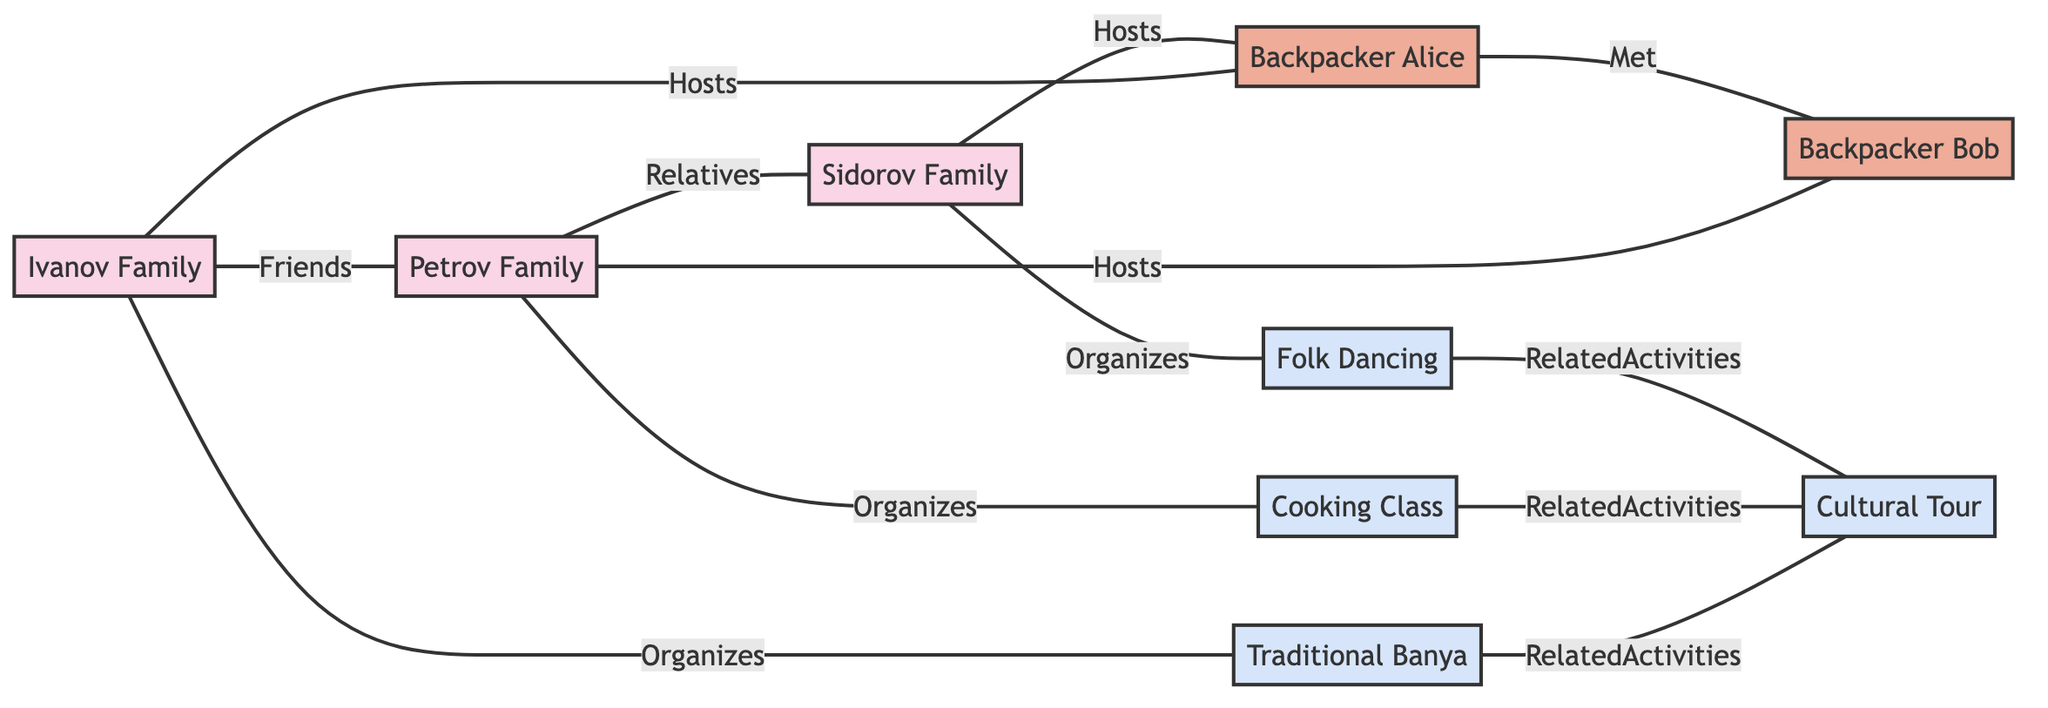What families host Backpacker Alice? The diagram shows two edges connecting the Ivanov Family and the Sidorov Family to Backpacker Alice, indicating that both families host her.
Answer: Ivanov Family, Sidorov Family How many activities are organized by the families? The diagram illustrates three activities: Banya Activity organized by the Ivanov Family, Cooking Class by the Petrov Family, and Folk Dancing by the Sidorov Family, which totals three activities.
Answer: 3 Who are the relatives of the Petrov Family? The edge labeled 'Relatives' connects the Petrov Family to the Sidorov Family, indicating that the Sidorov Family is a relative of the Petrov Family.
Answer: Sidorov Family What is the relationship between Banya Activity and Cultural Tour? The diagram connects Banya Activity and Cultural Tour through a related activities edge, indicating that they are associated with each other.
Answer: Related Activities Which backpacker met Backpacker Bob? According to the edge labeled 'Met', Backpacker Alice is connected to Backpacker Bob, revealing that she is the one who met him.
Answer: Backpacker Alice Which activity is organized by Family Sidorov? The diagram shows an edge labeled 'Organizes' that connects Family Sidorov to Folk Dancing, indicating that the Sidorov Family organizes this activity.
Answer: Folk Dancing Who are friends with the Ivanov Family? Looking at the edge labeled 'Friends', the Ivanov Family is connected to the Petrov Family, meaning they are friends.
Answer: Petrov Family How many total nodes represent families in the diagram? The diagram clearly shows three nodes that represent local families: the Ivanov Family, Petrov Family, and Sidorov Family. This gives us a total of three family nodes.
Answer: 3 What is the total number of edges in the diagram? By counting all the connections shown in the diagram (six edges connecting hosts, relationships, and activities), we find there are a total of twelve edges.
Answer: 12 